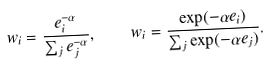Convert formula to latex. <formula><loc_0><loc_0><loc_500><loc_500>w _ { i } = \frac { e _ { i } ^ { - \alpha } } { \sum _ { j } e _ { j } ^ { - \alpha } } , \quad w _ { i } = \frac { \exp ( - \alpha e _ { i } ) } { \sum _ { j } \exp ( - \alpha e _ { j } ) } .</formula> 